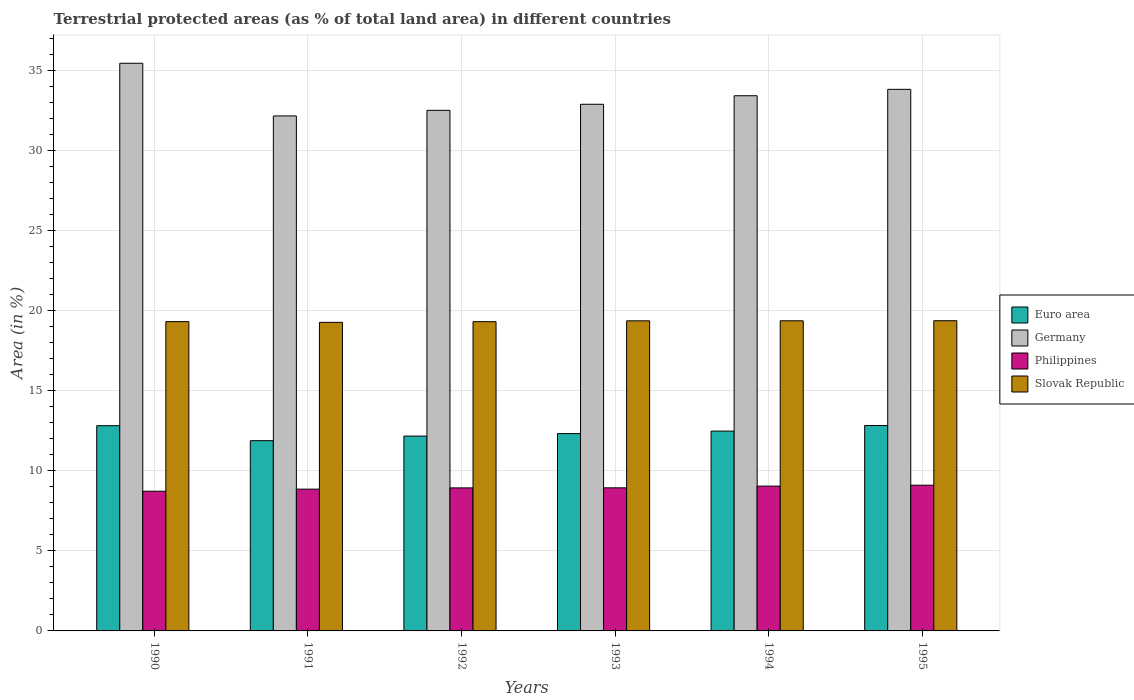How many groups of bars are there?
Provide a succinct answer. 6. Are the number of bars per tick equal to the number of legend labels?
Provide a short and direct response. Yes. How many bars are there on the 3rd tick from the right?
Make the answer very short. 4. What is the label of the 3rd group of bars from the left?
Keep it short and to the point. 1992. In how many cases, is the number of bars for a given year not equal to the number of legend labels?
Provide a succinct answer. 0. What is the percentage of terrestrial protected land in Slovak Republic in 1990?
Keep it short and to the point. 19.33. Across all years, what is the maximum percentage of terrestrial protected land in Euro area?
Make the answer very short. 12.84. Across all years, what is the minimum percentage of terrestrial protected land in Germany?
Provide a succinct answer. 32.19. What is the total percentage of terrestrial protected land in Slovak Republic in the graph?
Give a very brief answer. 116.11. What is the difference between the percentage of terrestrial protected land in Euro area in 1992 and that in 1995?
Give a very brief answer. -0.66. What is the difference between the percentage of terrestrial protected land in Slovak Republic in 1992 and the percentage of terrestrial protected land in Philippines in 1994?
Give a very brief answer. 10.28. What is the average percentage of terrestrial protected land in Philippines per year?
Offer a terse response. 8.94. In the year 1995, what is the difference between the percentage of terrestrial protected land in Slovak Republic and percentage of terrestrial protected land in Euro area?
Give a very brief answer. 6.55. In how many years, is the percentage of terrestrial protected land in Slovak Republic greater than 11 %?
Ensure brevity in your answer.  6. What is the ratio of the percentage of terrestrial protected land in Germany in 1992 to that in 1993?
Your answer should be compact. 0.99. Is the percentage of terrestrial protected land in Germany in 1990 less than that in 1993?
Provide a short and direct response. No. Is the difference between the percentage of terrestrial protected land in Slovak Republic in 1990 and 1995 greater than the difference between the percentage of terrestrial protected land in Euro area in 1990 and 1995?
Your answer should be compact. No. What is the difference between the highest and the second highest percentage of terrestrial protected land in Germany?
Offer a very short reply. 1.63. What is the difference between the highest and the lowest percentage of terrestrial protected land in Slovak Republic?
Make the answer very short. 0.1. In how many years, is the percentage of terrestrial protected land in Euro area greater than the average percentage of terrestrial protected land in Euro area taken over all years?
Your answer should be compact. 3. Is the sum of the percentage of terrestrial protected land in Germany in 1990 and 1992 greater than the maximum percentage of terrestrial protected land in Slovak Republic across all years?
Make the answer very short. Yes. What does the 4th bar from the left in 1992 represents?
Ensure brevity in your answer.  Slovak Republic. How many bars are there?
Make the answer very short. 24. Are all the bars in the graph horizontal?
Your response must be concise. No. How many years are there in the graph?
Offer a very short reply. 6. What is the difference between two consecutive major ticks on the Y-axis?
Offer a very short reply. 5. Does the graph contain any zero values?
Offer a very short reply. No. Where does the legend appear in the graph?
Your answer should be very brief. Center right. How many legend labels are there?
Your answer should be compact. 4. What is the title of the graph?
Provide a succinct answer. Terrestrial protected areas (as % of total land area) in different countries. What is the label or title of the Y-axis?
Ensure brevity in your answer.  Area (in %). What is the Area (in %) in Euro area in 1990?
Keep it short and to the point. 12.83. What is the Area (in %) in Germany in 1990?
Your answer should be compact. 35.48. What is the Area (in %) in Philippines in 1990?
Your response must be concise. 8.73. What is the Area (in %) of Slovak Republic in 1990?
Give a very brief answer. 19.33. What is the Area (in %) in Euro area in 1991?
Offer a terse response. 11.89. What is the Area (in %) in Germany in 1991?
Offer a very short reply. 32.19. What is the Area (in %) in Philippines in 1991?
Give a very brief answer. 8.86. What is the Area (in %) in Slovak Republic in 1991?
Provide a succinct answer. 19.29. What is the Area (in %) in Euro area in 1992?
Offer a very short reply. 12.18. What is the Area (in %) of Germany in 1992?
Keep it short and to the point. 32.54. What is the Area (in %) of Philippines in 1992?
Your answer should be very brief. 8.94. What is the Area (in %) in Slovak Republic in 1992?
Your response must be concise. 19.33. What is the Area (in %) of Euro area in 1993?
Give a very brief answer. 12.33. What is the Area (in %) of Germany in 1993?
Provide a short and direct response. 32.92. What is the Area (in %) of Philippines in 1993?
Your response must be concise. 8.94. What is the Area (in %) of Slovak Republic in 1993?
Your answer should be very brief. 19.38. What is the Area (in %) in Euro area in 1994?
Provide a short and direct response. 12.49. What is the Area (in %) in Germany in 1994?
Keep it short and to the point. 33.45. What is the Area (in %) of Philippines in 1994?
Keep it short and to the point. 9.05. What is the Area (in %) of Slovak Republic in 1994?
Your answer should be compact. 19.38. What is the Area (in %) in Euro area in 1995?
Make the answer very short. 12.84. What is the Area (in %) of Germany in 1995?
Offer a terse response. 33.85. What is the Area (in %) in Philippines in 1995?
Make the answer very short. 9.11. What is the Area (in %) of Slovak Republic in 1995?
Make the answer very short. 19.39. Across all years, what is the maximum Area (in %) in Euro area?
Provide a short and direct response. 12.84. Across all years, what is the maximum Area (in %) of Germany?
Keep it short and to the point. 35.48. Across all years, what is the maximum Area (in %) in Philippines?
Your answer should be compact. 9.11. Across all years, what is the maximum Area (in %) in Slovak Republic?
Your answer should be compact. 19.39. Across all years, what is the minimum Area (in %) of Euro area?
Your response must be concise. 11.89. Across all years, what is the minimum Area (in %) of Germany?
Make the answer very short. 32.19. Across all years, what is the minimum Area (in %) of Philippines?
Your answer should be compact. 8.73. Across all years, what is the minimum Area (in %) of Slovak Republic?
Your answer should be very brief. 19.29. What is the total Area (in %) in Euro area in the graph?
Your answer should be compact. 74.56. What is the total Area (in %) in Germany in the graph?
Ensure brevity in your answer.  200.43. What is the total Area (in %) of Philippines in the graph?
Your response must be concise. 53.64. What is the total Area (in %) of Slovak Republic in the graph?
Give a very brief answer. 116.11. What is the difference between the Area (in %) in Euro area in 1990 and that in 1991?
Your answer should be very brief. 0.94. What is the difference between the Area (in %) in Germany in 1990 and that in 1991?
Offer a terse response. 3.29. What is the difference between the Area (in %) of Philippines in 1990 and that in 1991?
Your answer should be compact. -0.13. What is the difference between the Area (in %) of Slovak Republic in 1990 and that in 1991?
Keep it short and to the point. 0.04. What is the difference between the Area (in %) of Euro area in 1990 and that in 1992?
Your response must be concise. 0.65. What is the difference between the Area (in %) of Germany in 1990 and that in 1992?
Provide a short and direct response. 2.94. What is the difference between the Area (in %) of Philippines in 1990 and that in 1992?
Your answer should be compact. -0.21. What is the difference between the Area (in %) of Slovak Republic in 1990 and that in 1992?
Offer a terse response. 0. What is the difference between the Area (in %) of Euro area in 1990 and that in 1993?
Your answer should be compact. 0.49. What is the difference between the Area (in %) in Germany in 1990 and that in 1993?
Provide a short and direct response. 2.56. What is the difference between the Area (in %) of Philippines in 1990 and that in 1993?
Ensure brevity in your answer.  -0.21. What is the difference between the Area (in %) of Slovak Republic in 1990 and that in 1993?
Give a very brief answer. -0.05. What is the difference between the Area (in %) in Euro area in 1990 and that in 1994?
Provide a short and direct response. 0.34. What is the difference between the Area (in %) of Germany in 1990 and that in 1994?
Make the answer very short. 2.03. What is the difference between the Area (in %) in Philippines in 1990 and that in 1994?
Give a very brief answer. -0.32. What is the difference between the Area (in %) of Slovak Republic in 1990 and that in 1994?
Provide a succinct answer. -0.05. What is the difference between the Area (in %) in Euro area in 1990 and that in 1995?
Offer a terse response. -0.01. What is the difference between the Area (in %) of Germany in 1990 and that in 1995?
Ensure brevity in your answer.  1.63. What is the difference between the Area (in %) in Philippines in 1990 and that in 1995?
Provide a succinct answer. -0.38. What is the difference between the Area (in %) in Slovak Republic in 1990 and that in 1995?
Ensure brevity in your answer.  -0.06. What is the difference between the Area (in %) in Euro area in 1991 and that in 1992?
Make the answer very short. -0.29. What is the difference between the Area (in %) of Germany in 1991 and that in 1992?
Provide a succinct answer. -0.35. What is the difference between the Area (in %) of Philippines in 1991 and that in 1992?
Provide a succinct answer. -0.08. What is the difference between the Area (in %) of Slovak Republic in 1991 and that in 1992?
Offer a very short reply. -0.04. What is the difference between the Area (in %) of Euro area in 1991 and that in 1993?
Your answer should be compact. -0.44. What is the difference between the Area (in %) of Germany in 1991 and that in 1993?
Keep it short and to the point. -0.73. What is the difference between the Area (in %) of Philippines in 1991 and that in 1993?
Offer a terse response. -0.08. What is the difference between the Area (in %) in Slovak Republic in 1991 and that in 1993?
Provide a short and direct response. -0.09. What is the difference between the Area (in %) of Euro area in 1991 and that in 1994?
Give a very brief answer. -0.6. What is the difference between the Area (in %) of Germany in 1991 and that in 1994?
Offer a terse response. -1.26. What is the difference between the Area (in %) in Philippines in 1991 and that in 1994?
Give a very brief answer. -0.19. What is the difference between the Area (in %) in Slovak Republic in 1991 and that in 1994?
Keep it short and to the point. -0.1. What is the difference between the Area (in %) of Euro area in 1991 and that in 1995?
Offer a terse response. -0.95. What is the difference between the Area (in %) of Germany in 1991 and that in 1995?
Make the answer very short. -1.66. What is the difference between the Area (in %) of Philippines in 1991 and that in 1995?
Offer a terse response. -0.25. What is the difference between the Area (in %) of Slovak Republic in 1991 and that in 1995?
Your response must be concise. -0.1. What is the difference between the Area (in %) of Euro area in 1992 and that in 1993?
Give a very brief answer. -0.16. What is the difference between the Area (in %) in Germany in 1992 and that in 1993?
Ensure brevity in your answer.  -0.38. What is the difference between the Area (in %) of Philippines in 1992 and that in 1993?
Ensure brevity in your answer.  -0. What is the difference between the Area (in %) of Slovak Republic in 1992 and that in 1993?
Offer a very short reply. -0.05. What is the difference between the Area (in %) of Euro area in 1992 and that in 1994?
Your answer should be very brief. -0.31. What is the difference between the Area (in %) in Germany in 1992 and that in 1994?
Provide a short and direct response. -0.91. What is the difference between the Area (in %) in Philippines in 1992 and that in 1994?
Provide a short and direct response. -0.11. What is the difference between the Area (in %) in Slovak Republic in 1992 and that in 1994?
Provide a short and direct response. -0.05. What is the difference between the Area (in %) in Euro area in 1992 and that in 1995?
Keep it short and to the point. -0.66. What is the difference between the Area (in %) in Germany in 1992 and that in 1995?
Your response must be concise. -1.31. What is the difference between the Area (in %) in Philippines in 1992 and that in 1995?
Your response must be concise. -0.17. What is the difference between the Area (in %) in Slovak Republic in 1992 and that in 1995?
Provide a short and direct response. -0.06. What is the difference between the Area (in %) of Euro area in 1993 and that in 1994?
Offer a terse response. -0.16. What is the difference between the Area (in %) of Germany in 1993 and that in 1994?
Provide a succinct answer. -0.53. What is the difference between the Area (in %) in Philippines in 1993 and that in 1994?
Provide a succinct answer. -0.1. What is the difference between the Area (in %) in Slovak Republic in 1993 and that in 1994?
Offer a terse response. -0. What is the difference between the Area (in %) of Euro area in 1993 and that in 1995?
Make the answer very short. -0.51. What is the difference between the Area (in %) in Germany in 1993 and that in 1995?
Your answer should be very brief. -0.93. What is the difference between the Area (in %) in Philippines in 1993 and that in 1995?
Your answer should be very brief. -0.16. What is the difference between the Area (in %) in Slovak Republic in 1993 and that in 1995?
Offer a very short reply. -0.01. What is the difference between the Area (in %) in Euro area in 1994 and that in 1995?
Provide a short and direct response. -0.35. What is the difference between the Area (in %) of Germany in 1994 and that in 1995?
Make the answer very short. -0.4. What is the difference between the Area (in %) in Philippines in 1994 and that in 1995?
Offer a very short reply. -0.06. What is the difference between the Area (in %) of Slovak Republic in 1994 and that in 1995?
Provide a succinct answer. -0. What is the difference between the Area (in %) in Euro area in 1990 and the Area (in %) in Germany in 1991?
Provide a short and direct response. -19.36. What is the difference between the Area (in %) of Euro area in 1990 and the Area (in %) of Philippines in 1991?
Offer a very short reply. 3.97. What is the difference between the Area (in %) of Euro area in 1990 and the Area (in %) of Slovak Republic in 1991?
Offer a very short reply. -6.46. What is the difference between the Area (in %) of Germany in 1990 and the Area (in %) of Philippines in 1991?
Provide a short and direct response. 26.62. What is the difference between the Area (in %) in Germany in 1990 and the Area (in %) in Slovak Republic in 1991?
Ensure brevity in your answer.  16.19. What is the difference between the Area (in %) of Philippines in 1990 and the Area (in %) of Slovak Republic in 1991?
Provide a short and direct response. -10.56. What is the difference between the Area (in %) of Euro area in 1990 and the Area (in %) of Germany in 1992?
Provide a succinct answer. -19.71. What is the difference between the Area (in %) in Euro area in 1990 and the Area (in %) in Philippines in 1992?
Offer a very short reply. 3.89. What is the difference between the Area (in %) in Euro area in 1990 and the Area (in %) in Slovak Republic in 1992?
Keep it short and to the point. -6.5. What is the difference between the Area (in %) in Germany in 1990 and the Area (in %) in Philippines in 1992?
Ensure brevity in your answer.  26.54. What is the difference between the Area (in %) of Germany in 1990 and the Area (in %) of Slovak Republic in 1992?
Keep it short and to the point. 16.15. What is the difference between the Area (in %) of Philippines in 1990 and the Area (in %) of Slovak Republic in 1992?
Your answer should be compact. -10.6. What is the difference between the Area (in %) of Euro area in 1990 and the Area (in %) of Germany in 1993?
Your answer should be compact. -20.09. What is the difference between the Area (in %) in Euro area in 1990 and the Area (in %) in Philippines in 1993?
Your answer should be very brief. 3.88. What is the difference between the Area (in %) of Euro area in 1990 and the Area (in %) of Slovak Republic in 1993?
Make the answer very short. -6.55. What is the difference between the Area (in %) in Germany in 1990 and the Area (in %) in Philippines in 1993?
Provide a short and direct response. 26.54. What is the difference between the Area (in %) in Germany in 1990 and the Area (in %) in Slovak Republic in 1993?
Offer a very short reply. 16.1. What is the difference between the Area (in %) of Philippines in 1990 and the Area (in %) of Slovak Republic in 1993?
Offer a terse response. -10.65. What is the difference between the Area (in %) of Euro area in 1990 and the Area (in %) of Germany in 1994?
Give a very brief answer. -20.62. What is the difference between the Area (in %) of Euro area in 1990 and the Area (in %) of Philippines in 1994?
Provide a succinct answer. 3.78. What is the difference between the Area (in %) of Euro area in 1990 and the Area (in %) of Slovak Republic in 1994?
Provide a succinct answer. -6.56. What is the difference between the Area (in %) in Germany in 1990 and the Area (in %) in Philippines in 1994?
Your response must be concise. 26.43. What is the difference between the Area (in %) of Germany in 1990 and the Area (in %) of Slovak Republic in 1994?
Provide a succinct answer. 16.1. What is the difference between the Area (in %) of Philippines in 1990 and the Area (in %) of Slovak Republic in 1994?
Your answer should be compact. -10.65. What is the difference between the Area (in %) in Euro area in 1990 and the Area (in %) in Germany in 1995?
Your response must be concise. -21.02. What is the difference between the Area (in %) of Euro area in 1990 and the Area (in %) of Philippines in 1995?
Your answer should be compact. 3.72. What is the difference between the Area (in %) in Euro area in 1990 and the Area (in %) in Slovak Republic in 1995?
Keep it short and to the point. -6.56. What is the difference between the Area (in %) of Germany in 1990 and the Area (in %) of Philippines in 1995?
Keep it short and to the point. 26.37. What is the difference between the Area (in %) in Germany in 1990 and the Area (in %) in Slovak Republic in 1995?
Your response must be concise. 16.09. What is the difference between the Area (in %) in Philippines in 1990 and the Area (in %) in Slovak Republic in 1995?
Give a very brief answer. -10.66. What is the difference between the Area (in %) in Euro area in 1991 and the Area (in %) in Germany in 1992?
Keep it short and to the point. -20.65. What is the difference between the Area (in %) in Euro area in 1991 and the Area (in %) in Philippines in 1992?
Make the answer very short. 2.95. What is the difference between the Area (in %) of Euro area in 1991 and the Area (in %) of Slovak Republic in 1992?
Your answer should be compact. -7.44. What is the difference between the Area (in %) in Germany in 1991 and the Area (in %) in Philippines in 1992?
Provide a succinct answer. 23.25. What is the difference between the Area (in %) of Germany in 1991 and the Area (in %) of Slovak Republic in 1992?
Offer a very short reply. 12.86. What is the difference between the Area (in %) in Philippines in 1991 and the Area (in %) in Slovak Republic in 1992?
Keep it short and to the point. -10.47. What is the difference between the Area (in %) of Euro area in 1991 and the Area (in %) of Germany in 1993?
Provide a succinct answer. -21.03. What is the difference between the Area (in %) in Euro area in 1991 and the Area (in %) in Philippines in 1993?
Provide a short and direct response. 2.95. What is the difference between the Area (in %) of Euro area in 1991 and the Area (in %) of Slovak Republic in 1993?
Keep it short and to the point. -7.49. What is the difference between the Area (in %) in Germany in 1991 and the Area (in %) in Philippines in 1993?
Offer a terse response. 23.24. What is the difference between the Area (in %) of Germany in 1991 and the Area (in %) of Slovak Republic in 1993?
Ensure brevity in your answer.  12.81. What is the difference between the Area (in %) of Philippines in 1991 and the Area (in %) of Slovak Republic in 1993?
Your answer should be very brief. -10.52. What is the difference between the Area (in %) in Euro area in 1991 and the Area (in %) in Germany in 1994?
Provide a succinct answer. -21.56. What is the difference between the Area (in %) in Euro area in 1991 and the Area (in %) in Philippines in 1994?
Provide a short and direct response. 2.84. What is the difference between the Area (in %) in Euro area in 1991 and the Area (in %) in Slovak Republic in 1994?
Keep it short and to the point. -7.49. What is the difference between the Area (in %) in Germany in 1991 and the Area (in %) in Philippines in 1994?
Provide a short and direct response. 23.14. What is the difference between the Area (in %) in Germany in 1991 and the Area (in %) in Slovak Republic in 1994?
Your answer should be very brief. 12.8. What is the difference between the Area (in %) in Philippines in 1991 and the Area (in %) in Slovak Republic in 1994?
Offer a terse response. -10.52. What is the difference between the Area (in %) in Euro area in 1991 and the Area (in %) in Germany in 1995?
Offer a terse response. -21.96. What is the difference between the Area (in %) of Euro area in 1991 and the Area (in %) of Philippines in 1995?
Provide a short and direct response. 2.78. What is the difference between the Area (in %) in Euro area in 1991 and the Area (in %) in Slovak Republic in 1995?
Make the answer very short. -7.5. What is the difference between the Area (in %) in Germany in 1991 and the Area (in %) in Philippines in 1995?
Your response must be concise. 23.08. What is the difference between the Area (in %) of Germany in 1991 and the Area (in %) of Slovak Republic in 1995?
Give a very brief answer. 12.8. What is the difference between the Area (in %) in Philippines in 1991 and the Area (in %) in Slovak Republic in 1995?
Provide a short and direct response. -10.53. What is the difference between the Area (in %) in Euro area in 1992 and the Area (in %) in Germany in 1993?
Give a very brief answer. -20.74. What is the difference between the Area (in %) in Euro area in 1992 and the Area (in %) in Philippines in 1993?
Provide a succinct answer. 3.23. What is the difference between the Area (in %) of Euro area in 1992 and the Area (in %) of Slovak Republic in 1993?
Your answer should be compact. -7.2. What is the difference between the Area (in %) of Germany in 1992 and the Area (in %) of Philippines in 1993?
Keep it short and to the point. 23.59. What is the difference between the Area (in %) of Germany in 1992 and the Area (in %) of Slovak Republic in 1993?
Your answer should be compact. 13.16. What is the difference between the Area (in %) of Philippines in 1992 and the Area (in %) of Slovak Republic in 1993?
Your answer should be compact. -10.44. What is the difference between the Area (in %) in Euro area in 1992 and the Area (in %) in Germany in 1994?
Provide a short and direct response. -21.27. What is the difference between the Area (in %) of Euro area in 1992 and the Area (in %) of Philippines in 1994?
Your answer should be compact. 3.13. What is the difference between the Area (in %) in Euro area in 1992 and the Area (in %) in Slovak Republic in 1994?
Provide a short and direct response. -7.21. What is the difference between the Area (in %) in Germany in 1992 and the Area (in %) in Philippines in 1994?
Your answer should be compact. 23.49. What is the difference between the Area (in %) in Germany in 1992 and the Area (in %) in Slovak Republic in 1994?
Ensure brevity in your answer.  13.15. What is the difference between the Area (in %) in Philippines in 1992 and the Area (in %) in Slovak Republic in 1994?
Give a very brief answer. -10.44. What is the difference between the Area (in %) of Euro area in 1992 and the Area (in %) of Germany in 1995?
Keep it short and to the point. -21.67. What is the difference between the Area (in %) in Euro area in 1992 and the Area (in %) in Philippines in 1995?
Your response must be concise. 3.07. What is the difference between the Area (in %) in Euro area in 1992 and the Area (in %) in Slovak Republic in 1995?
Your response must be concise. -7.21. What is the difference between the Area (in %) in Germany in 1992 and the Area (in %) in Philippines in 1995?
Your answer should be very brief. 23.43. What is the difference between the Area (in %) of Germany in 1992 and the Area (in %) of Slovak Republic in 1995?
Your response must be concise. 13.15. What is the difference between the Area (in %) of Philippines in 1992 and the Area (in %) of Slovak Republic in 1995?
Keep it short and to the point. -10.45. What is the difference between the Area (in %) in Euro area in 1993 and the Area (in %) in Germany in 1994?
Your response must be concise. -21.12. What is the difference between the Area (in %) in Euro area in 1993 and the Area (in %) in Philippines in 1994?
Your answer should be compact. 3.28. What is the difference between the Area (in %) in Euro area in 1993 and the Area (in %) in Slovak Republic in 1994?
Provide a succinct answer. -7.05. What is the difference between the Area (in %) in Germany in 1993 and the Area (in %) in Philippines in 1994?
Keep it short and to the point. 23.87. What is the difference between the Area (in %) in Germany in 1993 and the Area (in %) in Slovak Republic in 1994?
Your answer should be compact. 13.53. What is the difference between the Area (in %) in Philippines in 1993 and the Area (in %) in Slovak Republic in 1994?
Make the answer very short. -10.44. What is the difference between the Area (in %) of Euro area in 1993 and the Area (in %) of Germany in 1995?
Provide a short and direct response. -21.52. What is the difference between the Area (in %) of Euro area in 1993 and the Area (in %) of Philippines in 1995?
Provide a succinct answer. 3.23. What is the difference between the Area (in %) in Euro area in 1993 and the Area (in %) in Slovak Republic in 1995?
Provide a short and direct response. -7.05. What is the difference between the Area (in %) in Germany in 1993 and the Area (in %) in Philippines in 1995?
Give a very brief answer. 23.81. What is the difference between the Area (in %) in Germany in 1993 and the Area (in %) in Slovak Republic in 1995?
Make the answer very short. 13.53. What is the difference between the Area (in %) in Philippines in 1993 and the Area (in %) in Slovak Republic in 1995?
Your answer should be very brief. -10.44. What is the difference between the Area (in %) in Euro area in 1994 and the Area (in %) in Germany in 1995?
Ensure brevity in your answer.  -21.36. What is the difference between the Area (in %) in Euro area in 1994 and the Area (in %) in Philippines in 1995?
Your answer should be very brief. 3.38. What is the difference between the Area (in %) of Euro area in 1994 and the Area (in %) of Slovak Republic in 1995?
Provide a short and direct response. -6.9. What is the difference between the Area (in %) in Germany in 1994 and the Area (in %) in Philippines in 1995?
Make the answer very short. 24.34. What is the difference between the Area (in %) of Germany in 1994 and the Area (in %) of Slovak Republic in 1995?
Your response must be concise. 14.06. What is the difference between the Area (in %) in Philippines in 1994 and the Area (in %) in Slovak Republic in 1995?
Your answer should be very brief. -10.34. What is the average Area (in %) in Euro area per year?
Ensure brevity in your answer.  12.43. What is the average Area (in %) of Germany per year?
Offer a very short reply. 33.41. What is the average Area (in %) of Philippines per year?
Your answer should be compact. 8.94. What is the average Area (in %) in Slovak Republic per year?
Provide a succinct answer. 19.35. In the year 1990, what is the difference between the Area (in %) of Euro area and Area (in %) of Germany?
Offer a very short reply. -22.65. In the year 1990, what is the difference between the Area (in %) in Euro area and Area (in %) in Philippines?
Your response must be concise. 4.1. In the year 1990, what is the difference between the Area (in %) of Euro area and Area (in %) of Slovak Republic?
Provide a succinct answer. -6.5. In the year 1990, what is the difference between the Area (in %) in Germany and Area (in %) in Philippines?
Your answer should be very brief. 26.75. In the year 1990, what is the difference between the Area (in %) of Germany and Area (in %) of Slovak Republic?
Your answer should be very brief. 16.15. In the year 1990, what is the difference between the Area (in %) in Philippines and Area (in %) in Slovak Republic?
Offer a terse response. -10.6. In the year 1991, what is the difference between the Area (in %) in Euro area and Area (in %) in Germany?
Your answer should be very brief. -20.3. In the year 1991, what is the difference between the Area (in %) of Euro area and Area (in %) of Philippines?
Ensure brevity in your answer.  3.03. In the year 1991, what is the difference between the Area (in %) of Euro area and Area (in %) of Slovak Republic?
Ensure brevity in your answer.  -7.4. In the year 1991, what is the difference between the Area (in %) in Germany and Area (in %) in Philippines?
Your answer should be compact. 23.33. In the year 1991, what is the difference between the Area (in %) in Germany and Area (in %) in Slovak Republic?
Ensure brevity in your answer.  12.9. In the year 1991, what is the difference between the Area (in %) in Philippines and Area (in %) in Slovak Republic?
Your answer should be compact. -10.43. In the year 1992, what is the difference between the Area (in %) of Euro area and Area (in %) of Germany?
Ensure brevity in your answer.  -20.36. In the year 1992, what is the difference between the Area (in %) of Euro area and Area (in %) of Philippines?
Make the answer very short. 3.24. In the year 1992, what is the difference between the Area (in %) in Euro area and Area (in %) in Slovak Republic?
Your response must be concise. -7.15. In the year 1992, what is the difference between the Area (in %) in Germany and Area (in %) in Philippines?
Offer a very short reply. 23.6. In the year 1992, what is the difference between the Area (in %) of Germany and Area (in %) of Slovak Republic?
Offer a very short reply. 13.21. In the year 1992, what is the difference between the Area (in %) in Philippines and Area (in %) in Slovak Republic?
Keep it short and to the point. -10.39. In the year 1993, what is the difference between the Area (in %) of Euro area and Area (in %) of Germany?
Your answer should be very brief. -20.58. In the year 1993, what is the difference between the Area (in %) in Euro area and Area (in %) in Philippines?
Provide a succinct answer. 3.39. In the year 1993, what is the difference between the Area (in %) of Euro area and Area (in %) of Slovak Republic?
Offer a terse response. -7.05. In the year 1993, what is the difference between the Area (in %) of Germany and Area (in %) of Philippines?
Ensure brevity in your answer.  23.97. In the year 1993, what is the difference between the Area (in %) in Germany and Area (in %) in Slovak Republic?
Offer a terse response. 13.54. In the year 1993, what is the difference between the Area (in %) in Philippines and Area (in %) in Slovak Republic?
Keep it short and to the point. -10.44. In the year 1994, what is the difference between the Area (in %) of Euro area and Area (in %) of Germany?
Keep it short and to the point. -20.96. In the year 1994, what is the difference between the Area (in %) in Euro area and Area (in %) in Philippines?
Offer a terse response. 3.44. In the year 1994, what is the difference between the Area (in %) in Euro area and Area (in %) in Slovak Republic?
Your answer should be very brief. -6.89. In the year 1994, what is the difference between the Area (in %) in Germany and Area (in %) in Philippines?
Offer a terse response. 24.4. In the year 1994, what is the difference between the Area (in %) in Germany and Area (in %) in Slovak Republic?
Ensure brevity in your answer.  14.07. In the year 1994, what is the difference between the Area (in %) in Philippines and Area (in %) in Slovak Republic?
Provide a short and direct response. -10.34. In the year 1995, what is the difference between the Area (in %) in Euro area and Area (in %) in Germany?
Make the answer very short. -21.01. In the year 1995, what is the difference between the Area (in %) of Euro area and Area (in %) of Philippines?
Provide a short and direct response. 3.73. In the year 1995, what is the difference between the Area (in %) in Euro area and Area (in %) in Slovak Republic?
Your answer should be compact. -6.55. In the year 1995, what is the difference between the Area (in %) in Germany and Area (in %) in Philippines?
Ensure brevity in your answer.  24.74. In the year 1995, what is the difference between the Area (in %) of Germany and Area (in %) of Slovak Republic?
Make the answer very short. 14.46. In the year 1995, what is the difference between the Area (in %) in Philippines and Area (in %) in Slovak Republic?
Offer a very short reply. -10.28. What is the ratio of the Area (in %) in Euro area in 1990 to that in 1991?
Your answer should be very brief. 1.08. What is the ratio of the Area (in %) in Germany in 1990 to that in 1991?
Offer a very short reply. 1.1. What is the ratio of the Area (in %) of Philippines in 1990 to that in 1991?
Your response must be concise. 0.99. What is the ratio of the Area (in %) in Euro area in 1990 to that in 1992?
Provide a succinct answer. 1.05. What is the ratio of the Area (in %) of Germany in 1990 to that in 1992?
Keep it short and to the point. 1.09. What is the ratio of the Area (in %) in Philippines in 1990 to that in 1992?
Keep it short and to the point. 0.98. What is the ratio of the Area (in %) of Slovak Republic in 1990 to that in 1992?
Offer a terse response. 1. What is the ratio of the Area (in %) of Germany in 1990 to that in 1993?
Provide a short and direct response. 1.08. What is the ratio of the Area (in %) in Philippines in 1990 to that in 1993?
Offer a very short reply. 0.98. What is the ratio of the Area (in %) in Slovak Republic in 1990 to that in 1993?
Your response must be concise. 1. What is the ratio of the Area (in %) in Germany in 1990 to that in 1994?
Offer a very short reply. 1.06. What is the ratio of the Area (in %) of Philippines in 1990 to that in 1994?
Your response must be concise. 0.96. What is the ratio of the Area (in %) of Slovak Republic in 1990 to that in 1994?
Your answer should be compact. 1. What is the ratio of the Area (in %) in Germany in 1990 to that in 1995?
Offer a very short reply. 1.05. What is the ratio of the Area (in %) of Philippines in 1990 to that in 1995?
Keep it short and to the point. 0.96. What is the ratio of the Area (in %) of Slovak Republic in 1990 to that in 1995?
Provide a succinct answer. 1. What is the ratio of the Area (in %) of Euro area in 1991 to that in 1992?
Provide a succinct answer. 0.98. What is the ratio of the Area (in %) in Germany in 1991 to that in 1992?
Keep it short and to the point. 0.99. What is the ratio of the Area (in %) of Philippines in 1991 to that in 1992?
Your response must be concise. 0.99. What is the ratio of the Area (in %) in Euro area in 1991 to that in 1993?
Your response must be concise. 0.96. What is the ratio of the Area (in %) of Germany in 1991 to that in 1993?
Your answer should be very brief. 0.98. What is the ratio of the Area (in %) in Slovak Republic in 1991 to that in 1993?
Your answer should be very brief. 1. What is the ratio of the Area (in %) of Euro area in 1991 to that in 1994?
Your answer should be very brief. 0.95. What is the ratio of the Area (in %) of Germany in 1991 to that in 1994?
Offer a very short reply. 0.96. What is the ratio of the Area (in %) of Philippines in 1991 to that in 1994?
Your response must be concise. 0.98. What is the ratio of the Area (in %) in Euro area in 1991 to that in 1995?
Offer a terse response. 0.93. What is the ratio of the Area (in %) in Germany in 1991 to that in 1995?
Provide a succinct answer. 0.95. What is the ratio of the Area (in %) in Philippines in 1991 to that in 1995?
Offer a very short reply. 0.97. What is the ratio of the Area (in %) of Euro area in 1992 to that in 1993?
Give a very brief answer. 0.99. What is the ratio of the Area (in %) of Euro area in 1992 to that in 1994?
Offer a terse response. 0.97. What is the ratio of the Area (in %) in Germany in 1992 to that in 1994?
Offer a terse response. 0.97. What is the ratio of the Area (in %) in Philippines in 1992 to that in 1994?
Provide a succinct answer. 0.99. What is the ratio of the Area (in %) in Slovak Republic in 1992 to that in 1994?
Provide a short and direct response. 1. What is the ratio of the Area (in %) in Euro area in 1992 to that in 1995?
Your answer should be very brief. 0.95. What is the ratio of the Area (in %) in Germany in 1992 to that in 1995?
Your response must be concise. 0.96. What is the ratio of the Area (in %) of Philippines in 1992 to that in 1995?
Give a very brief answer. 0.98. What is the ratio of the Area (in %) in Euro area in 1993 to that in 1994?
Make the answer very short. 0.99. What is the ratio of the Area (in %) in Germany in 1993 to that in 1994?
Your response must be concise. 0.98. What is the ratio of the Area (in %) in Philippines in 1993 to that in 1994?
Your response must be concise. 0.99. What is the ratio of the Area (in %) of Euro area in 1993 to that in 1995?
Offer a terse response. 0.96. What is the ratio of the Area (in %) of Germany in 1993 to that in 1995?
Provide a succinct answer. 0.97. What is the ratio of the Area (in %) in Philippines in 1993 to that in 1995?
Give a very brief answer. 0.98. What is the ratio of the Area (in %) of Slovak Republic in 1993 to that in 1995?
Your answer should be compact. 1. What is the ratio of the Area (in %) in Euro area in 1994 to that in 1995?
Offer a very short reply. 0.97. What is the ratio of the Area (in %) of Germany in 1994 to that in 1995?
Your response must be concise. 0.99. What is the ratio of the Area (in %) of Philippines in 1994 to that in 1995?
Your answer should be very brief. 0.99. What is the difference between the highest and the second highest Area (in %) in Euro area?
Your response must be concise. 0.01. What is the difference between the highest and the second highest Area (in %) of Germany?
Your answer should be very brief. 1.63. What is the difference between the highest and the second highest Area (in %) of Philippines?
Offer a very short reply. 0.06. What is the difference between the highest and the second highest Area (in %) of Slovak Republic?
Provide a short and direct response. 0. What is the difference between the highest and the lowest Area (in %) of Euro area?
Offer a very short reply. 0.95. What is the difference between the highest and the lowest Area (in %) in Germany?
Provide a succinct answer. 3.29. What is the difference between the highest and the lowest Area (in %) of Philippines?
Give a very brief answer. 0.38. What is the difference between the highest and the lowest Area (in %) in Slovak Republic?
Your answer should be very brief. 0.1. 